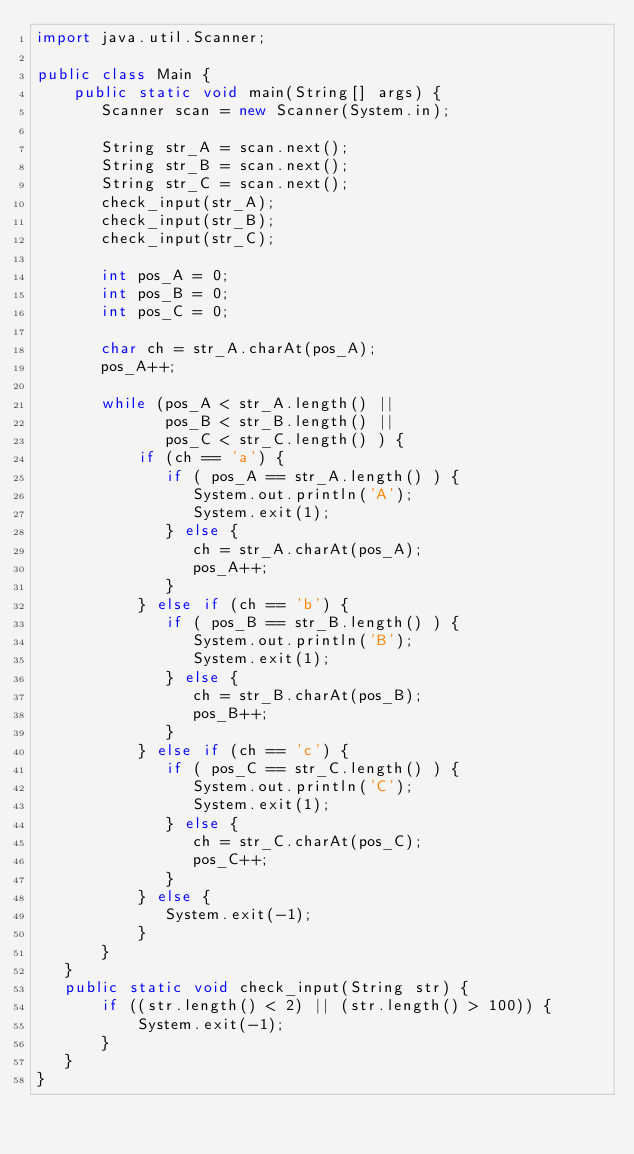<code> <loc_0><loc_0><loc_500><loc_500><_Java_>import java.util.Scanner;

public class Main {
    public static void main(String[] args) {
       Scanner scan = new Scanner(System.in);

       String str_A = scan.next();
       String str_B = scan.next();
       String str_C = scan.next();
       check_input(str_A);
       check_input(str_B);
       check_input(str_C);

       int pos_A = 0;
       int pos_B = 0;
       int pos_C = 0;

       char ch = str_A.charAt(pos_A);
       pos_A++;

       while (pos_A < str_A.length() ||
              pos_B < str_B.length() ||
              pos_C < str_C.length() ) {
           if (ch == 'a') {
              if ( pos_A == str_A.length() ) {
                 System.out.println('A');
                 System.exit(1);
              } else {
                 ch = str_A.charAt(pos_A);
                 pos_A++;
              }
           } else if (ch == 'b') {
              if ( pos_B == str_B.length() ) {
                 System.out.println('B');
                 System.exit(1);
              } else {
                 ch = str_B.charAt(pos_B);
                 pos_B++;
              }
           } else if (ch == 'c') {
              if ( pos_C == str_C.length() ) {
                 System.out.println('C');
                 System.exit(1);
              } else {
                 ch = str_C.charAt(pos_C);
                 pos_C++;
              }
           } else {
              System.exit(-1);
           }
       }
   }
   public static void check_input(String str) {
       if ((str.length() < 2) || (str.length() > 100)) {
           System.exit(-1);
       }
   }
}</code> 